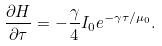<formula> <loc_0><loc_0><loc_500><loc_500>\frac { \partial H } { \partial \tau } = - \frac { \gamma } { 4 } I _ { 0 } e ^ { - \gamma \tau / \mu _ { 0 } } .</formula> 